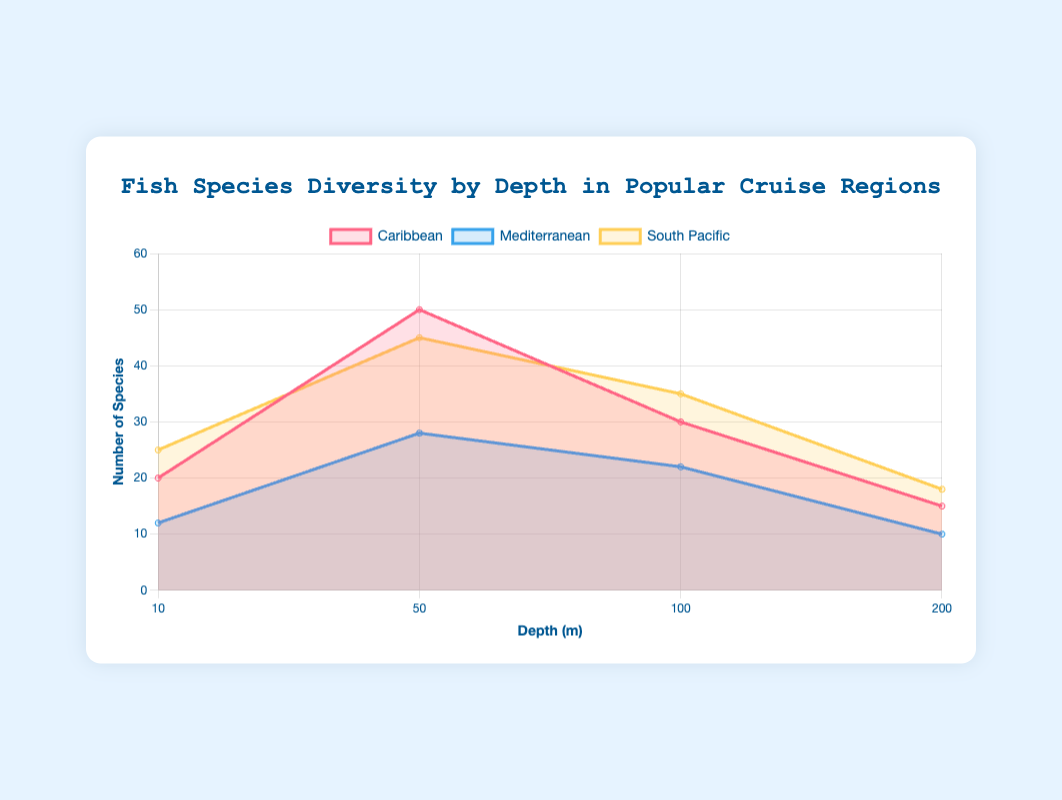What's the title of the figure? The title of the figure is usually located at the top and provides an overview of what the chart displays. In this case, the title is "Fish Species Diversity by Depth in Popular Cruise Regions".
Answer: Fish Species Diversity by Depth in Popular Cruise Regions Which region has the highest species count at 50 meters depth? To answer this, we look at the species count values for each region at 50 meters depth. The Caribbean displays 50 species, the Mediterranean shows 28 species, and the South Pacific indicates 45 species. The Caribbean has the highest count.
Answer: Caribbean What is the trend of the species count in the Caribbean as the depth increases from 10 to 200 meters? Observing the Caribbean region, the species count starts at 20 at 10 meters, increases to 50 at 50 meters, then decreases to 30 at 100 meters, and finally drops to 15 at 200 meters. The trend shows an initial increase followed by a decrease.
Answer: Initial increase, then decrease At what depth does the South Pacific have the maximum species count? In the South Pacific dataset, the species count is highest at 50 meters with 45 species. It has lower values at other depths (10 meters: 25 species, 100 meters: 35 species, 200 meters: 18 species).
Answer: 50 meters Which region has the least species diversity at 200 meters depth? Looking at 200 meters depth, the Caribbean has 15 species, the Mediterranean has 10 species, and the South Pacific has 18 species. Therefore, the Mediterranean has the least species diversity at this depth.
Answer: Mediterranean What’s the combined species count of all regions at 100 meters depth? For 100 meters depth, the species counts are: Caribbean 30, Mediterranean 22, and South Pacific 35. Summing them up gives: 30 + 22 + 35 = 87 species.
Answer: 87 Between 10 and 50 meters depth, which region sees the highest increase in species count? To find the region with the highest increase, we calculate the difference in species count for each region between 10 and 50 meters depth: Caribbean (50 - 20 = 30), Mediterranean (28 - 12 = 16), South Pacific (45 - 25 = 20). The Caribbean shows the highest increase.
Answer: Caribbean Which region maintains a consistent pattern of increasing or decreasing species count as the depth increases? Reviewing the data, the South Pacific has an increasing species count from 10 to 50 meters (25 to 45 species) and then a decreasing trend from 50 to 200 meters (45 to 18 species). Thus, it maintains a consistent pattern.
Answer: South Pacific How does the species count in the Mediterranean compare at shallow (10 meters) versus deep (200 meters) depths? In the Mediterranean, the species count is 12 at 10 meters and 10 at 200 meters, showing only a slight decrease. This indicates relatively stable species diversity at these depths.
Answer: Slight decrease What pattern do you observe in the species count across regions at 10 meters depth? At 10 meters depth, the Caribbean has 20 species, the Mediterranean has 12 species, and the South Pacific has 25 species. The pattern shows the South Pacific with the highest count, followed by the Caribbean and the Mediterranean with the lowest count.
Answer: South Pacific > Caribbean > Mediterranean 